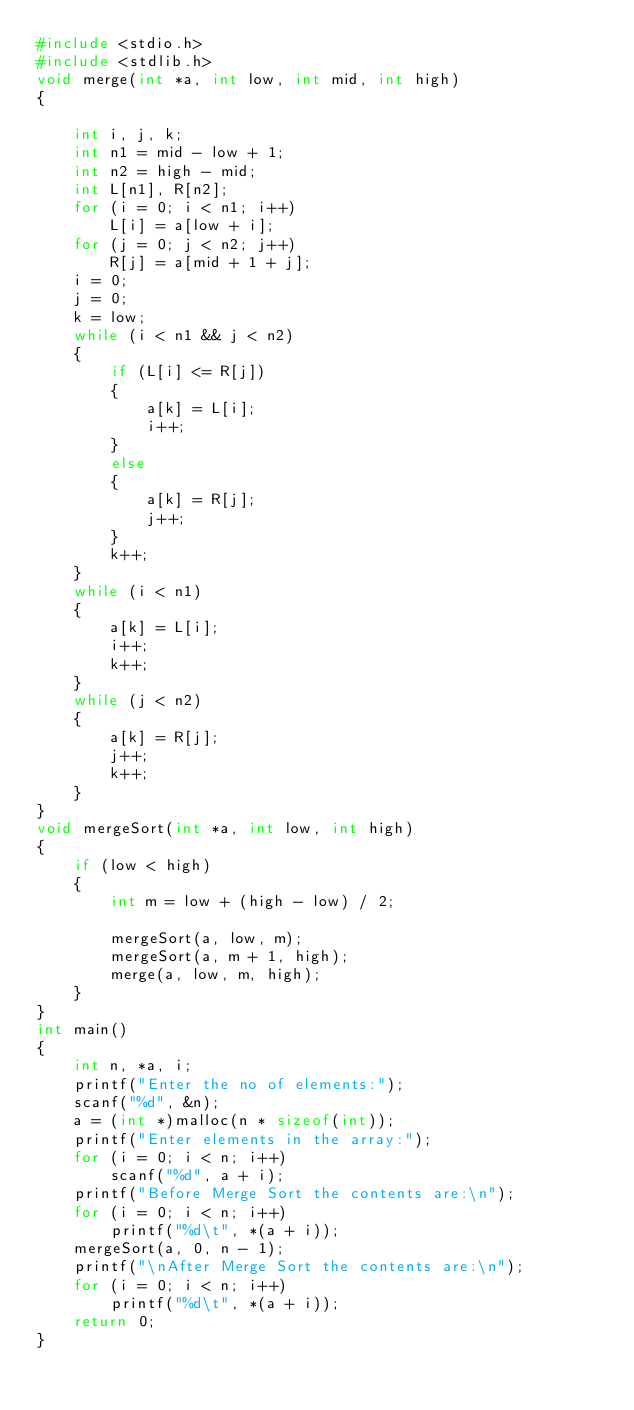Convert code to text. <code><loc_0><loc_0><loc_500><loc_500><_C_>#include <stdio.h>
#include <stdlib.h>
void merge(int *a, int low, int mid, int high)
{

    int i, j, k;
    int n1 = mid - low + 1;
    int n2 = high - mid;
    int L[n1], R[n2];
    for (i = 0; i < n1; i++)
        L[i] = a[low + i];
    for (j = 0; j < n2; j++)
        R[j] = a[mid + 1 + j];
    i = 0;
    j = 0;
    k = low;
    while (i < n1 && j < n2)
    {
        if (L[i] <= R[j])
        {
            a[k] = L[i];
            i++;
        }
        else
        {
            a[k] = R[j];
            j++;
        }
        k++;
    }
    while (i < n1)
    {
        a[k] = L[i];
        i++;
        k++;
    }
    while (j < n2)
    {
        a[k] = R[j];
        j++;
        k++;
    }
}
void mergeSort(int *a, int low, int high)
{
    if (low < high)
    {
        int m = low + (high - low) / 2;

        mergeSort(a, low, m);
        mergeSort(a, m + 1, high);
        merge(a, low, m, high);
    }
}
int main()
{
    int n, *a, i;
    printf("Enter the no of elements:");
    scanf("%d", &n);
    a = (int *)malloc(n * sizeof(int));
    printf("Enter elements in the array:");
    for (i = 0; i < n; i++)
        scanf("%d", a + i);
    printf("Before Merge Sort the contents are:\n");
    for (i = 0; i < n; i++)
        printf("%d\t", *(a + i));
    mergeSort(a, 0, n - 1);
    printf("\nAfter Merge Sort the contents are:\n");
    for (i = 0; i < n; i++)
        printf("%d\t", *(a + i));
    return 0;
}</code> 